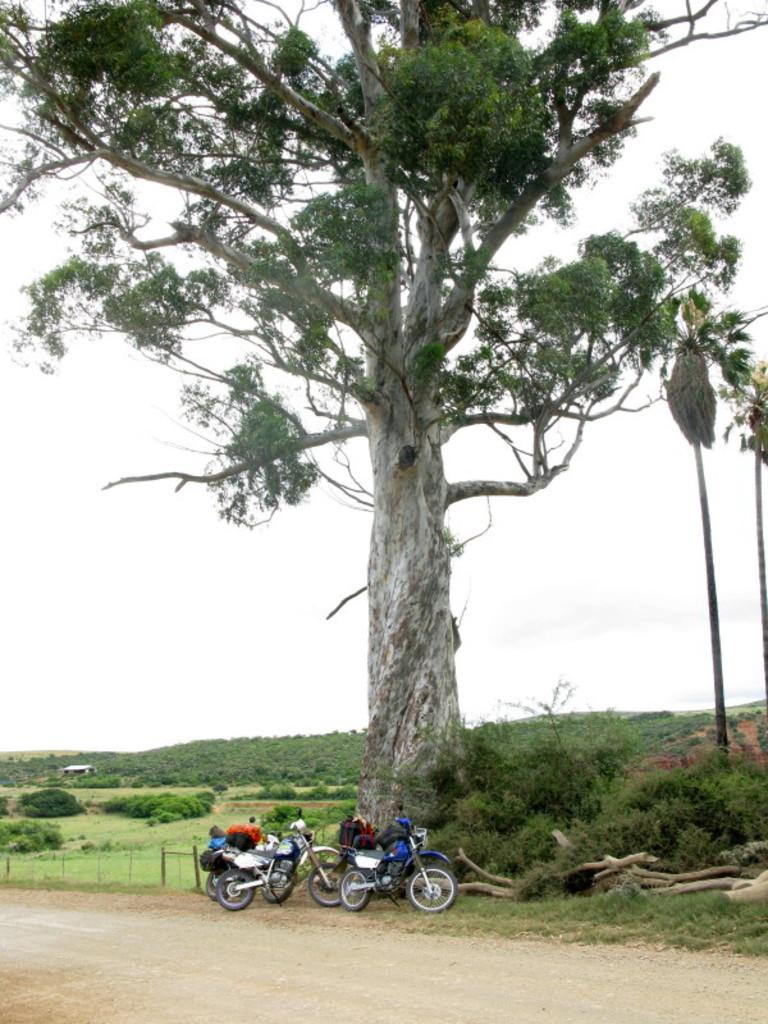What is on the bikes in the image? There are bags on the bikes in the image. How are the bikes positioned in the image? The bikes are on the ground. What can be seen in the image besides the bikes? There is a tree, a road, and the sky visible in the background of the image. What type of vegetation is present in the background of the image? There are plants, trees, and grass in the background of the image. What type of animals can be seen in the zoo in the image? There is no zoo present in the image; it features bikes with bags, a tree, a road, and the sky in the background. What is the list of items that need to be checked off before leaving the location in the image? There is no list or specific task mentioned in the image; it simply shows bikes with bags, a tree, a road, and the sky in the background. 